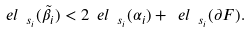<formula> <loc_0><loc_0><loc_500><loc_500>\ e l _ { \ s _ { i } } ( \tilde { \beta } _ { i } ) < 2 \ e l _ { \ s _ { i } } ( \alpha _ { i } ) + \ e l _ { \ s _ { i } } ( \partial F ) .</formula> 